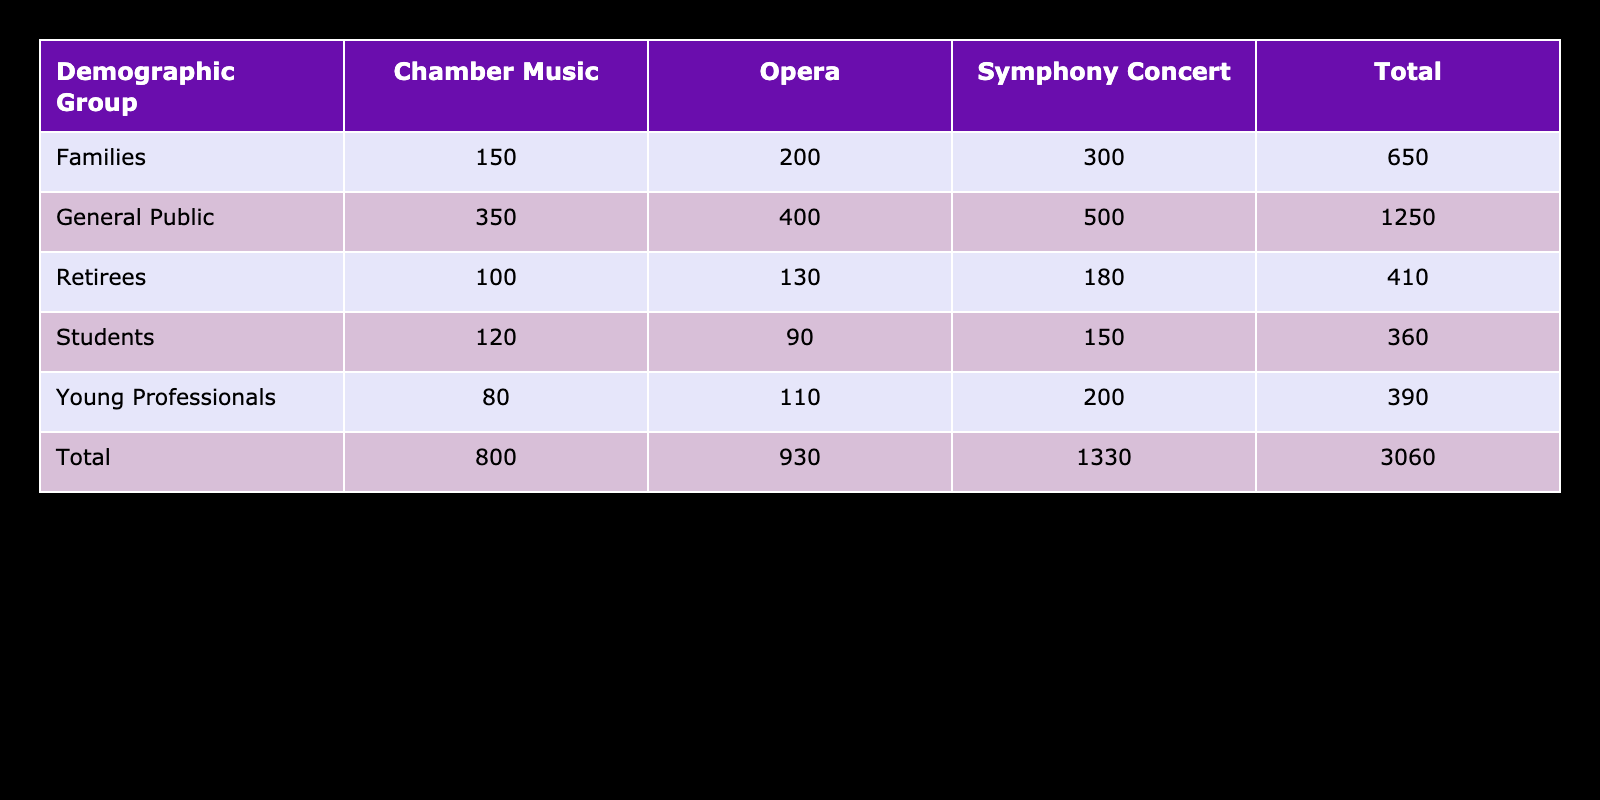What is the total attendance for Families at Symphony Concerts? From the table, the attendance for Families at Symphony Concerts is listed as 300. Since this is a single value from the table, no further calculations are needed.
Answer: 300 How many attendees participated in Chamber Music Concerts by Young Professionals? The table states the attendance for Young Professionals at Chamber Music Concerts is 80. This is a direct reading from the table.
Answer: 80 Which demographic group had the highest total attendance across all concert types? To find this, we can look at the total attendance for each group: Students (360), Young Professionals (390), Families (650), Retirees (410), and General Public (1250). The General Public has the highest total attendance.
Answer: General Public Are more students likely to attend Opera or Chamber Music events? The attendance for Students at Opera is 90, while for Chamber Music it is 120. Comparing these two numbers, it shows that more students attended Chamber Music events.
Answer: Yes What is the difference in attendance between Symphonic Concerts and Opera for the General Public? The attendance for the General Public at Symphony Concerts is 500, and at Opera, it is 400. The difference is calculated as 500 - 400 = 100. This shows that 100 more attendees were present at Symphony Concerts compared to Opera.
Answer: 100 What is the average attendance at Chamber Music events by Retirees and Young Professionals combined? The attendance for Retirees at Chamber Music is 100, and for Young Professionals, it is 80. Adding these two gives us 100 + 80 = 180. To find the average, we divide by 2 (the number of groups): 180 / 2 = 90.
Answer: 90 How many more families attended Opera than Young Professionals? The attendance is 200 for Families at Opera and 110 for Young Professionals. To find the difference, subtract Young Professionals from Families: 200 - 110 = 90. This indicates that 90 more Families attended Opera compared to Young Professionals.
Answer: 90 Is the total attendance of Retirees across all concert types greater than that of Students? The total attendance for Retirees is 410 (180 at Symphony, 100 at Chamber, 130 at Opera), while for Students, it is 360 (150 at Symphony, 120 at Chamber, 90 at Opera). Since 410 is greater than 360, we conclude that the attendance for Retirees is indeed higher.
Answer: Yes 